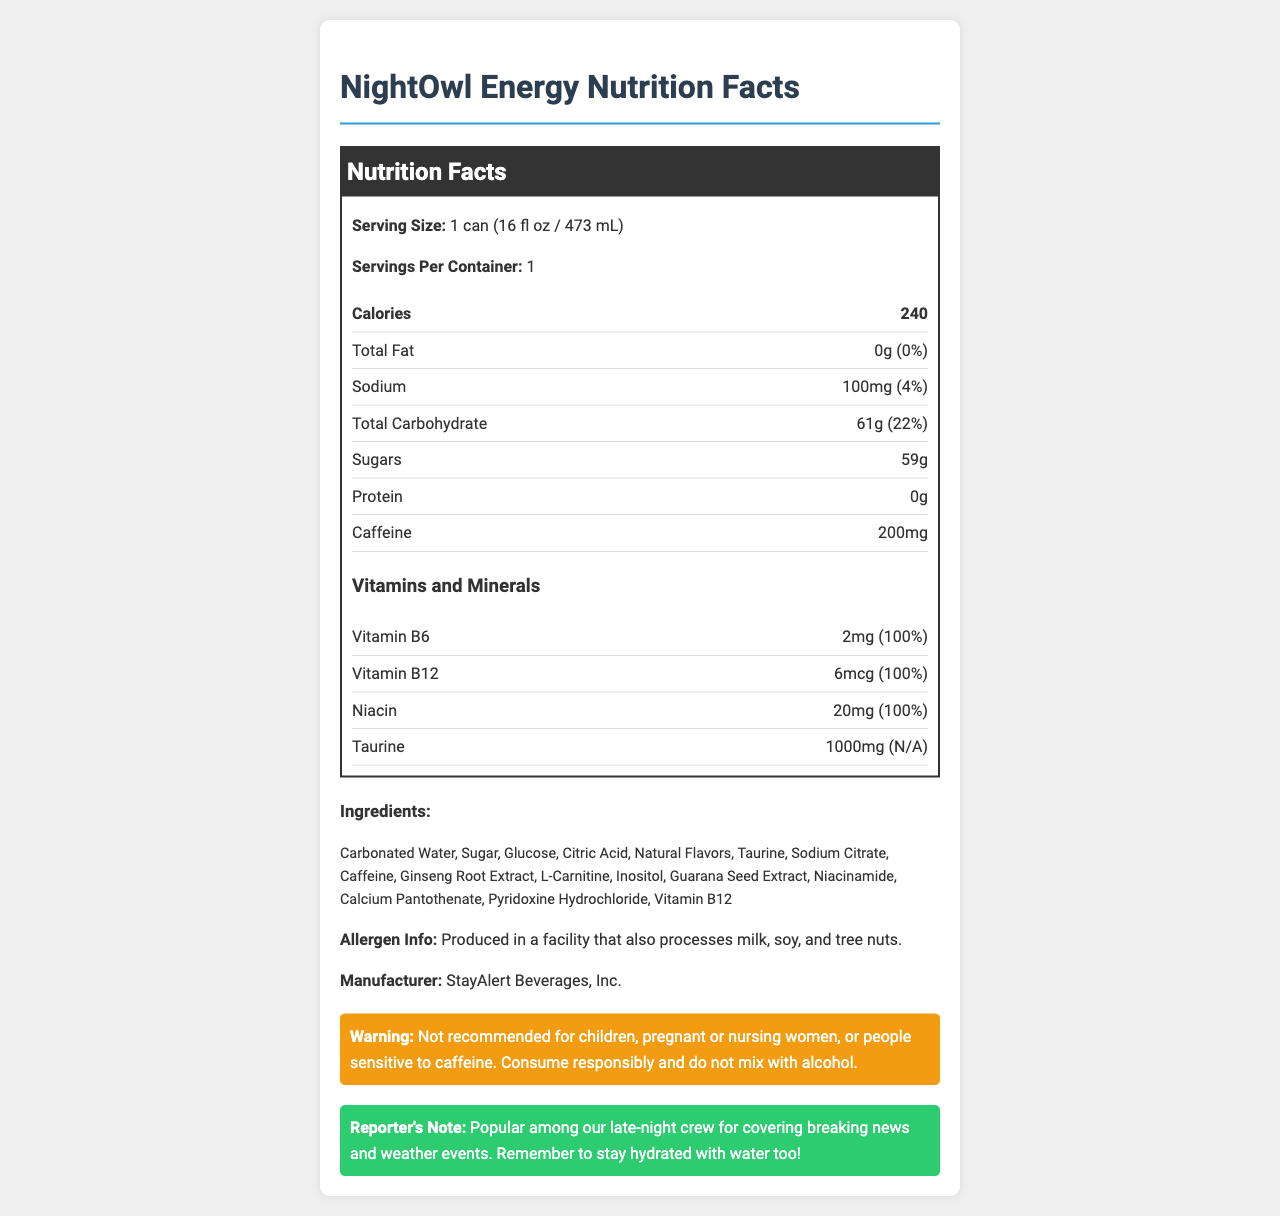what is the serving size for NightOwl Energy? The document states that the serving size for NightOwl Energy is 1 can (16 fl oz / 473 mL).
Answer: 1 can (16 fl oz / 473 mL) how many grams of sugar are in NightOwl Energy? The nutrition label lists the amount of sugar as 59g.
Answer: 59g what is the total amount of caffeine in one can? The document mentions that there are 200mg of caffeine in one can of NightOwl Energy.
Answer: 200mg which vitamin has the highest daily value percentage? The document shows that Vitamin B6, Vitamin B12, and Niacin each have a daily value of 100%.
Answer: Vitamin B6, Vitamin B12, and Niacin all have 100% daily value. what is the sodium content as a percentage of the daily value? The sodium content is listed as 100mg, which is 4% of the daily value.
Answer: 4% how many calories are in one can of NightOwl Energy? The document states that there are 240 calories per serving, which is one can.
Answer: 240 what is the total carbohydrate content in NightOwl Energy? The total carbohydrate content is listed as 61g, which is 22% of the daily value.
Answer: 61g (22% daily value) does NightOwl Energy contain protein? The document lists the protein content as 0g, indicating there is no protein in NightOwl Energy.
Answer: No what are the listed ingredients of NightOwl Energy? (Select all that apply)
A. Carbonated Water
B. High Fructose Corn Syrup
C. Sugar
D. Glucose
E. Lactic Acid The ingredients listed include Carbonated Water, Sugar, and Glucose. High Fructose Corn Syrup and Lactic Acid are not listed.
Answer: A, C, D which of the following warnings is associated with NightOwl Energy?
A. Do not exceed 2 cans per day.
B. Not recommended for children and pregnant women.
C. May cause drowsiness.
D. Contains dairy. The document warns that NightOwl Energy is "Not recommended for children, pregnant or nursing women, or people sensitive to caffeine."
Answer: B is NightOwl Energy suitable for individuals with tree nut allergies? The document mentions that NightOwl Energy is produced in a facility that also processes tree nuts.
Answer: No summarize the main points of the NightOwl Energy nutrition facts label. This summary captures the essential nutritional information, vitamins, ingredients, allergen information, and warnings provided in the document.
Answer: NightOwl Energy is an energy drink with 240 calories per can, containing substantial amounts of caffeine (200mg) and sugar (59g) but no fat or protein. It provides significant daily values for vitamins B6, B12, and Niacin (100% each). The ingredient list is extensive, including items such as carbonated water, sugar, glucose, and taurine. There is an allergen warning indicating the product is made in a facility that processes milk, soy, and tree nuts. There are specific consumption warnings for certain populations. when should NightOwl Energy not be consumed according to its warning label? The document's warning section indicates these guidelines.
Answer: Children, pregnant or nursing women, and people sensitive to caffeine should not consume NightOwl Energy. Additionally, it should not be mixed with alcohol and should be consumed responsibly. what is the origin of the glucose used in NightOwl Energy? The document lists "Glucose" as an ingredient but does not provide information on its origin.
Answer: Not enough information 